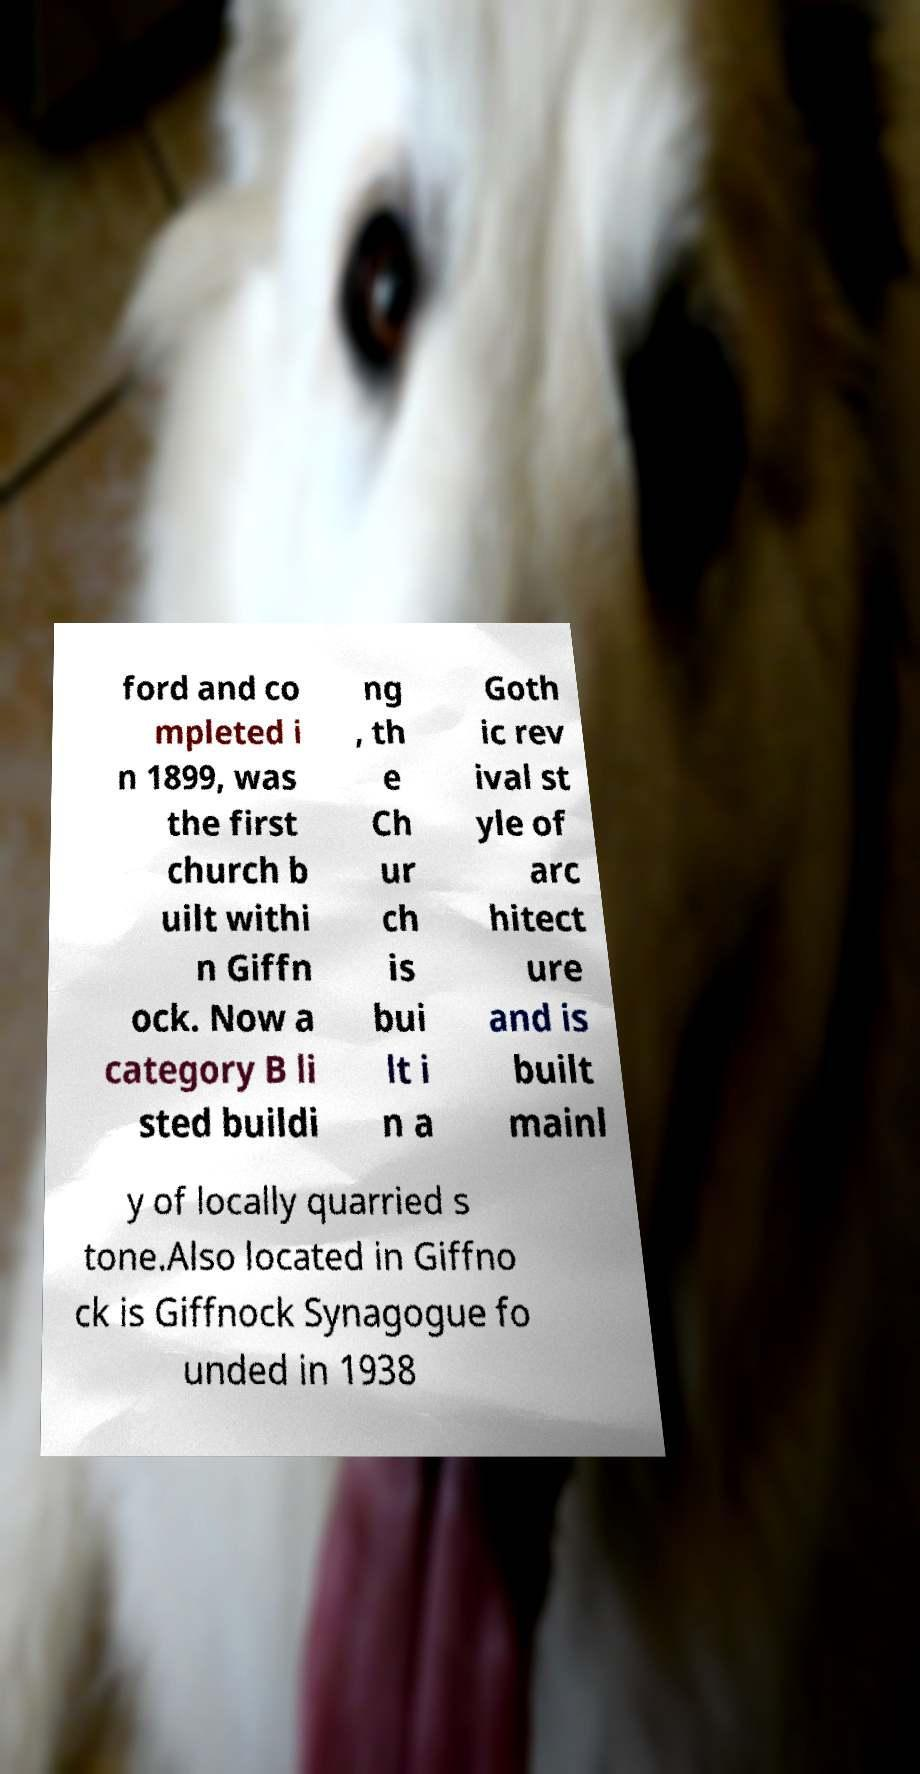Please identify and transcribe the text found in this image. ford and co mpleted i n 1899, was the first church b uilt withi n Giffn ock. Now a category B li sted buildi ng , th e Ch ur ch is bui lt i n a Goth ic rev ival st yle of arc hitect ure and is built mainl y of locally quarried s tone.Also located in Giffno ck is Giffnock Synagogue fo unded in 1938 